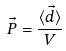<formula> <loc_0><loc_0><loc_500><loc_500>\vec { P } = \frac { \langle \vec { d } \rangle } { V }</formula> 